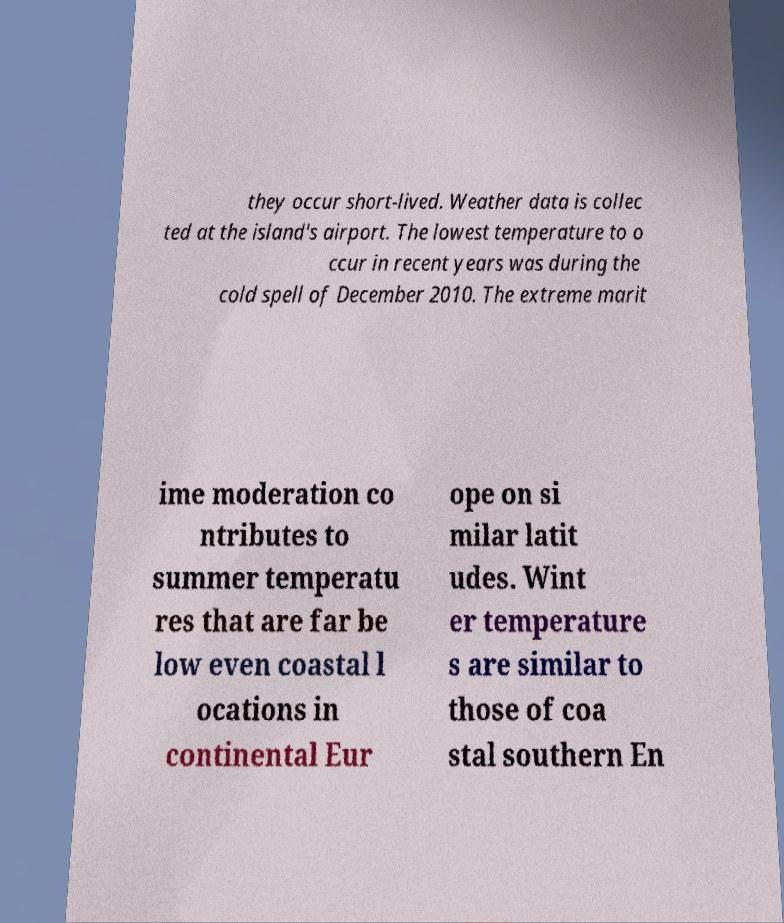For documentation purposes, I need the text within this image transcribed. Could you provide that? they occur short-lived. Weather data is collec ted at the island's airport. The lowest temperature to o ccur in recent years was during the cold spell of December 2010. The extreme marit ime moderation co ntributes to summer temperatu res that are far be low even coastal l ocations in continental Eur ope on si milar latit udes. Wint er temperature s are similar to those of coa stal southern En 